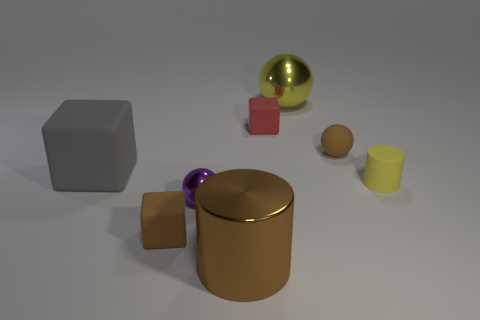There is a rubber cube that is on the right side of the small block that is in front of the brown matte thing to the right of the red matte block; what size is it? small 